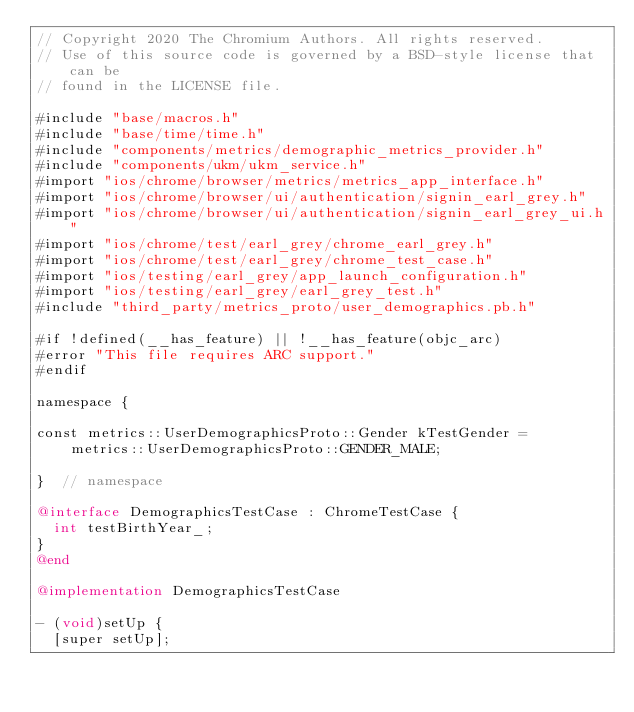<code> <loc_0><loc_0><loc_500><loc_500><_ObjectiveC_>// Copyright 2020 The Chromium Authors. All rights reserved.
// Use of this source code is governed by a BSD-style license that can be
// found in the LICENSE file.

#include "base/macros.h"
#include "base/time/time.h"
#include "components/metrics/demographic_metrics_provider.h"
#include "components/ukm/ukm_service.h"
#import "ios/chrome/browser/metrics/metrics_app_interface.h"
#import "ios/chrome/browser/ui/authentication/signin_earl_grey.h"
#import "ios/chrome/browser/ui/authentication/signin_earl_grey_ui.h"
#import "ios/chrome/test/earl_grey/chrome_earl_grey.h"
#import "ios/chrome/test/earl_grey/chrome_test_case.h"
#import "ios/testing/earl_grey/app_launch_configuration.h"
#import "ios/testing/earl_grey/earl_grey_test.h"
#include "third_party/metrics_proto/user_demographics.pb.h"

#if !defined(__has_feature) || !__has_feature(objc_arc)
#error "This file requires ARC support."
#endif

namespace {

const metrics::UserDemographicsProto::Gender kTestGender =
    metrics::UserDemographicsProto::GENDER_MALE;

}  // namespace

@interface DemographicsTestCase : ChromeTestCase {
  int testBirthYear_;
}
@end

@implementation DemographicsTestCase

- (void)setUp {
  [super setUp];</code> 